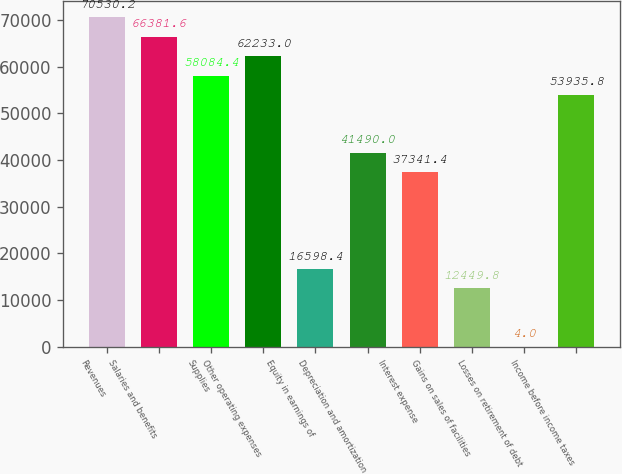Convert chart. <chart><loc_0><loc_0><loc_500><loc_500><bar_chart><fcel>Revenues<fcel>Salaries and benefits<fcel>Supplies<fcel>Other operating expenses<fcel>Equity in earnings of<fcel>Depreciation and amortization<fcel>Interest expense<fcel>Gains on sales of facilities<fcel>Losses on retirement of debt<fcel>Income before income taxes<nl><fcel>70530.2<fcel>66381.6<fcel>58084.4<fcel>62233<fcel>16598.4<fcel>41490<fcel>37341.4<fcel>12449.8<fcel>4<fcel>53935.8<nl></chart> 